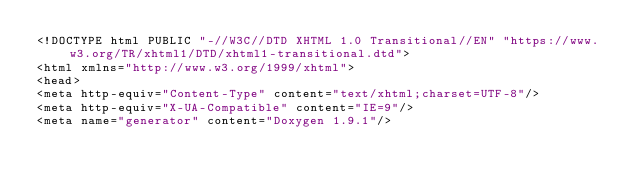<code> <loc_0><loc_0><loc_500><loc_500><_HTML_><!DOCTYPE html PUBLIC "-//W3C//DTD XHTML 1.0 Transitional//EN" "https://www.w3.org/TR/xhtml1/DTD/xhtml1-transitional.dtd">
<html xmlns="http://www.w3.org/1999/xhtml">
<head>
<meta http-equiv="Content-Type" content="text/xhtml;charset=UTF-8"/>
<meta http-equiv="X-UA-Compatible" content="IE=9"/>
<meta name="generator" content="Doxygen 1.9.1"/></code> 